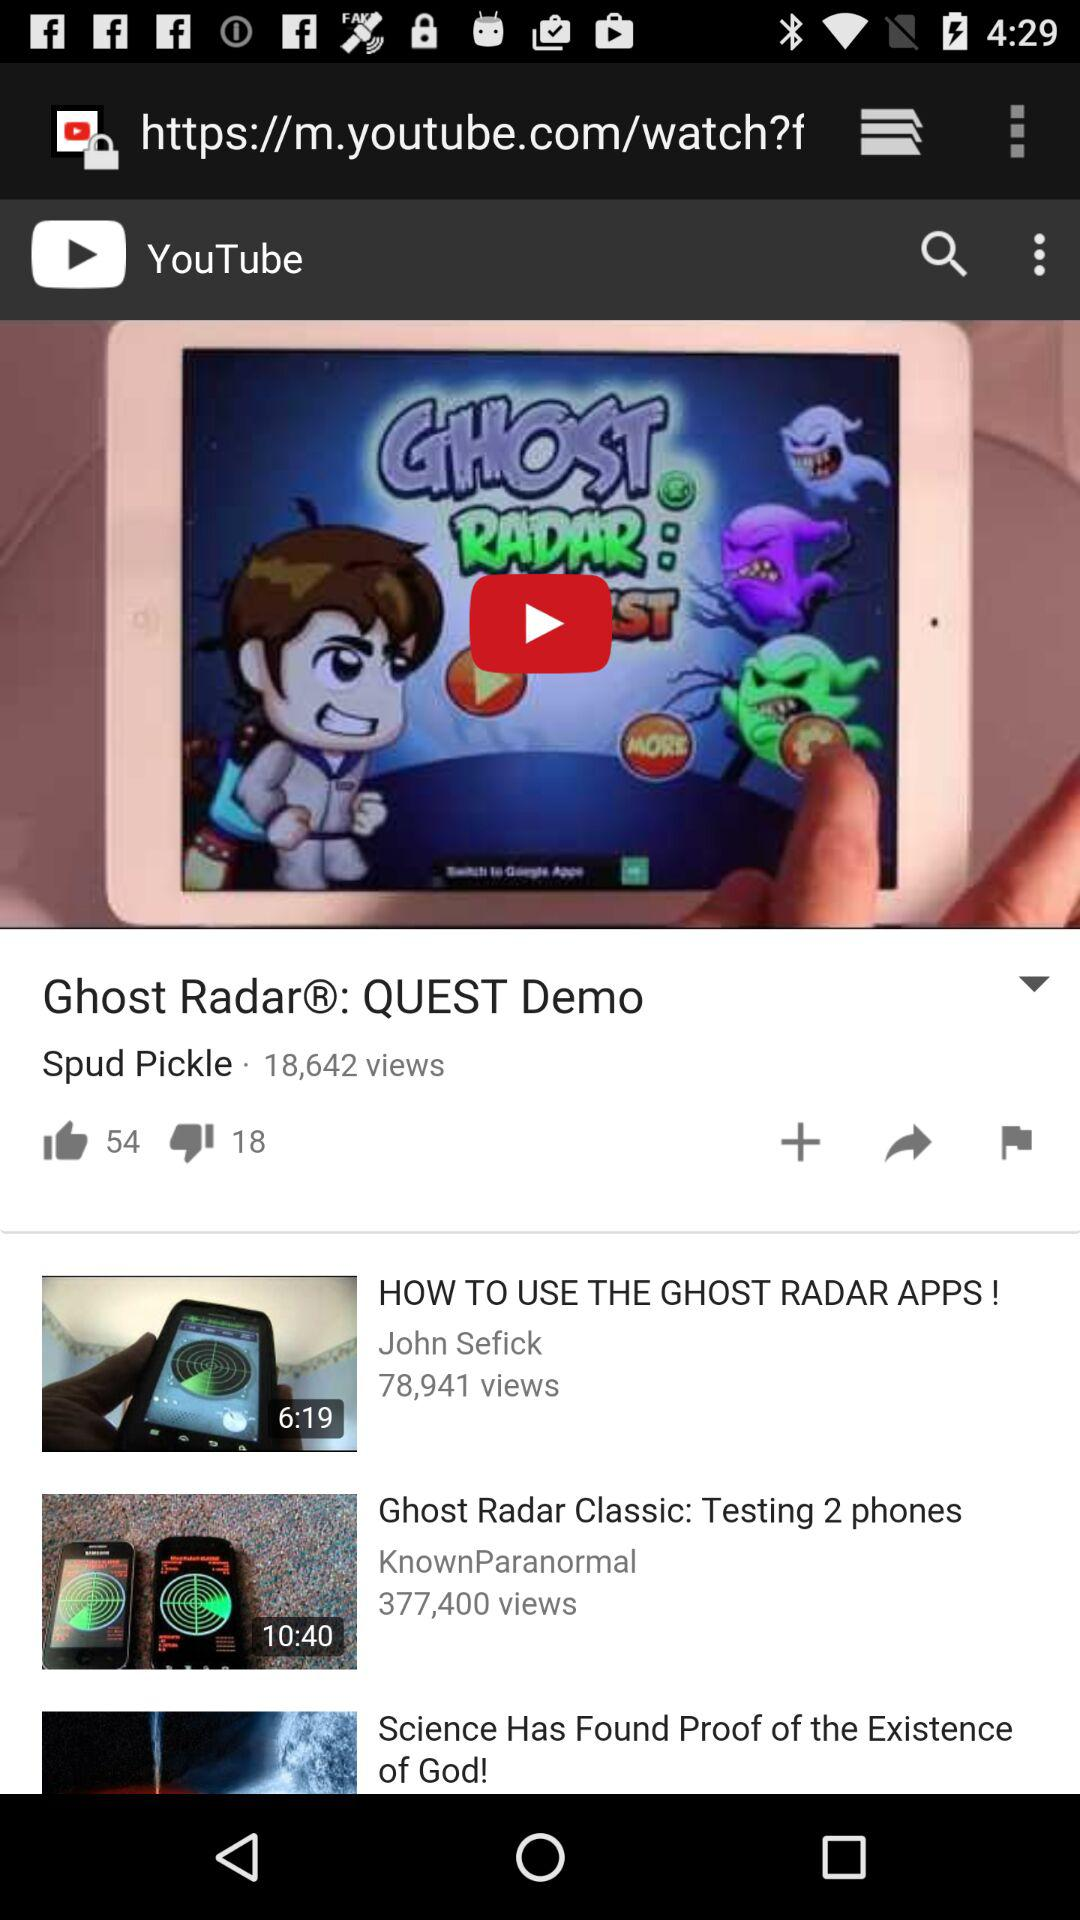What is the duration of the "HOW TO USE THE GHOST RADAR APPS!" video? The duration is 6 minutes and 19 seconds. 